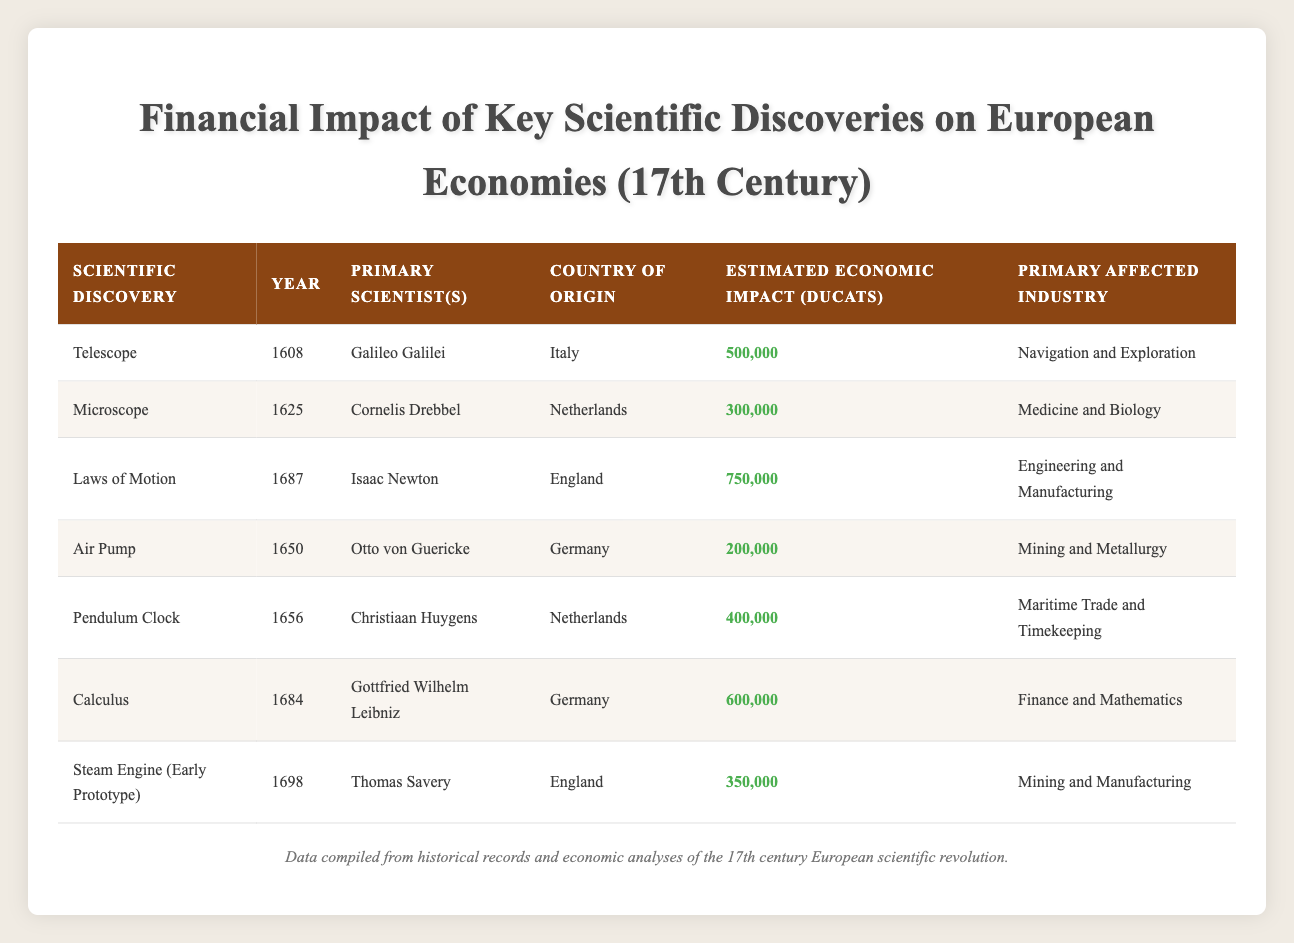What is the estimated economic impact of the Laws of Motion? The row for the "Laws of Motion" shows an estimated economic impact of 750,000 Ducats.
Answer: 750,000 Ducats Which scientist is credited with the invention of the telescope? According to the table, the telescope was invented by Galileo Galilei in 1608.
Answer: Galileo Galilei In which country was the microscope invented? The table indicates that the microscope was invented in the Netherlands.
Answer: Netherlands What is the total estimated economic impact of the discoveries made in Germany? The discoveries from Germany are the Air Pump (200,000 Ducats) and Calculus (600,000 Ducats). Adding these gives a total of 200,000 + 600,000 = 800,000 Ducats.
Answer: 800,000 Ducats Did any discovery have an estimated economic impact above 600,000 Ducats? Yes, the Laws of Motion had an estimated economic impact of 750,000 Ducats, which is above 600,000 Ducats.
Answer: Yes Which primary industry had the highest economic impact from scientific discoveries? By reviewing the estimated economic impacts, the Laws of Motion (750,000 Ducats) had the highest impact, primarily affecting Engineering and Manufacturing.
Answer: Engineering and Manufacturing What was the difference in economic impact between the Pendulum Clock and the Steam Engine? The Pendulum Clock had an economic impact of 400,000 Ducats while the Steam Engine (Early Prototype) had an impact of 350,000 Ducats. The difference is 400,000 - 350,000 = 50,000 Ducats.
Answer: 50,000 Ducats List the discoveries that had an economic impact between 300,000 and 500,000 Ducats. The discoveries that fit this criterion are the Microscope (300,000 Ducats), Pendulum Clock (400,000 Ducats), and Steam Engine (350,000 Ducats).
Answer: Microscope, Pendulum Clock, Steam Engine What was the earliest scientific discovery listed in the table? The table shows the earliest scientific discovery is the Telescope, invented in 1608.
Answer: Telescope 